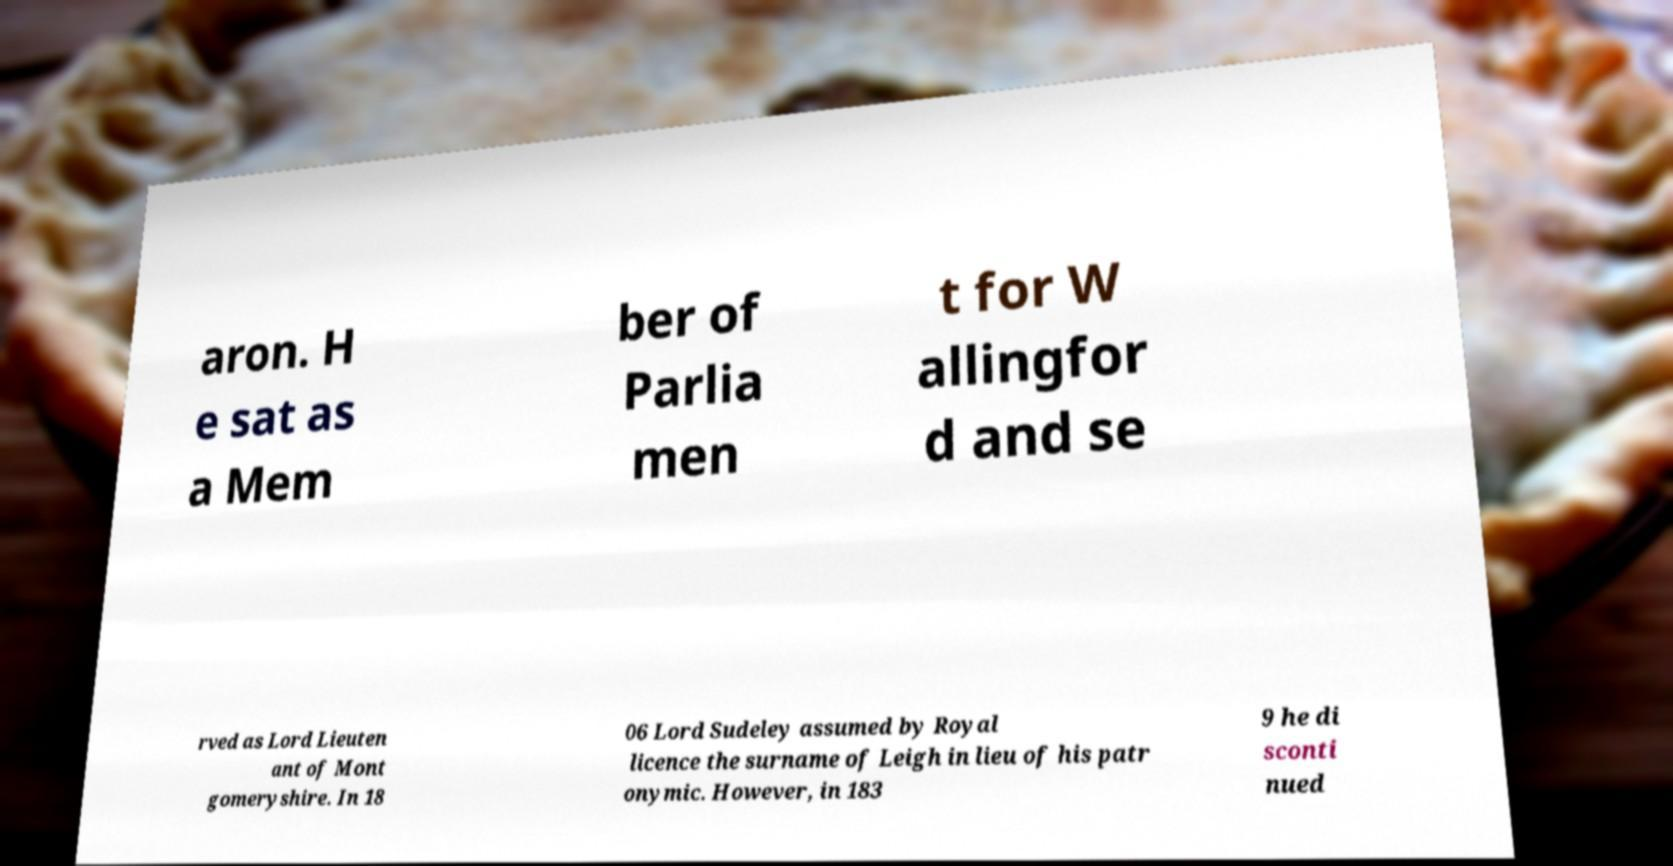Please identify and transcribe the text found in this image. aron. H e sat as a Mem ber of Parlia men t for W allingfor d and se rved as Lord Lieuten ant of Mont gomeryshire. In 18 06 Lord Sudeley assumed by Royal licence the surname of Leigh in lieu of his patr onymic. However, in 183 9 he di sconti nued 